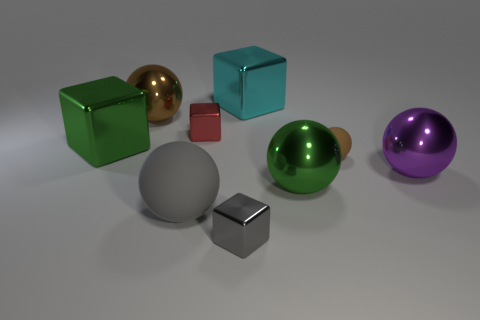Subtract 1 spheres. How many spheres are left? 4 Subtract all large purple metallic spheres. How many spheres are left? 4 Subtract all purple spheres. How many spheres are left? 4 Subtract all yellow spheres. Subtract all gray cubes. How many spheres are left? 5 Add 1 green spheres. How many objects exist? 10 Subtract all balls. How many objects are left? 4 Add 5 small objects. How many small objects are left? 8 Add 6 large purple objects. How many large purple objects exist? 7 Subtract 0 green cylinders. How many objects are left? 9 Subtract all cyan metal objects. Subtract all green shiny blocks. How many objects are left? 7 